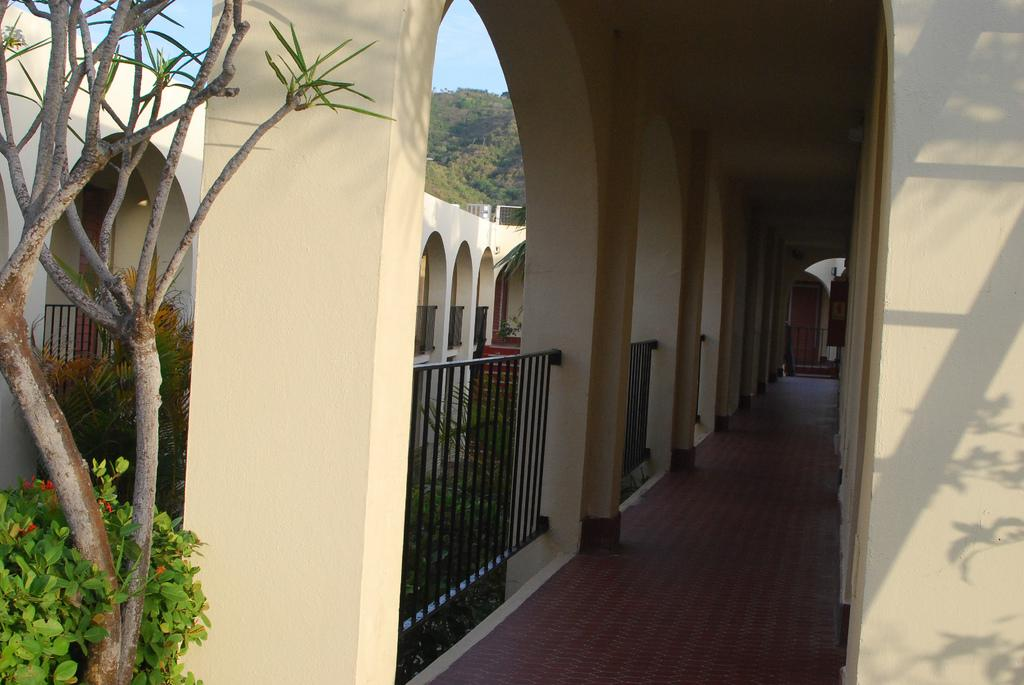What type of natural element is on the left side of the image? There is a tree on the left side of the image. What type of man-made structure is present in the image? There is a building in the image. What architectural feature can be seen on the building? The building has a veranda. What type of cord is hanging from the tree in the image? There is no cord hanging from the tree in the image. What kind of apparatus is attached to the building in the image? There is no apparatus attached to the building in the image. 